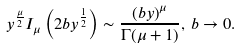<formula> <loc_0><loc_0><loc_500><loc_500>y ^ { \frac { \mu } { 2 } } I _ { \mu } \left ( 2 b y ^ { \frac { 1 } { 2 } } \right ) \sim \frac { \left ( b y \right ) ^ { \mu } } { \Gamma ( \mu + 1 ) } , \, b \rightarrow 0 .</formula> 